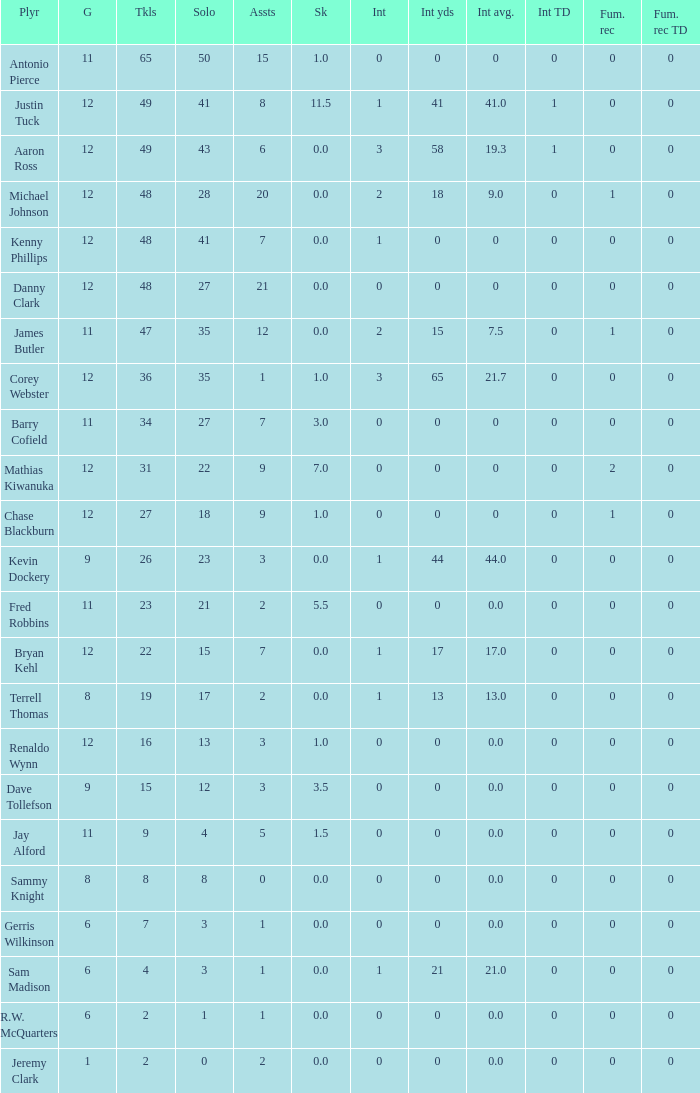Name the least amount of int yards 0.0. 